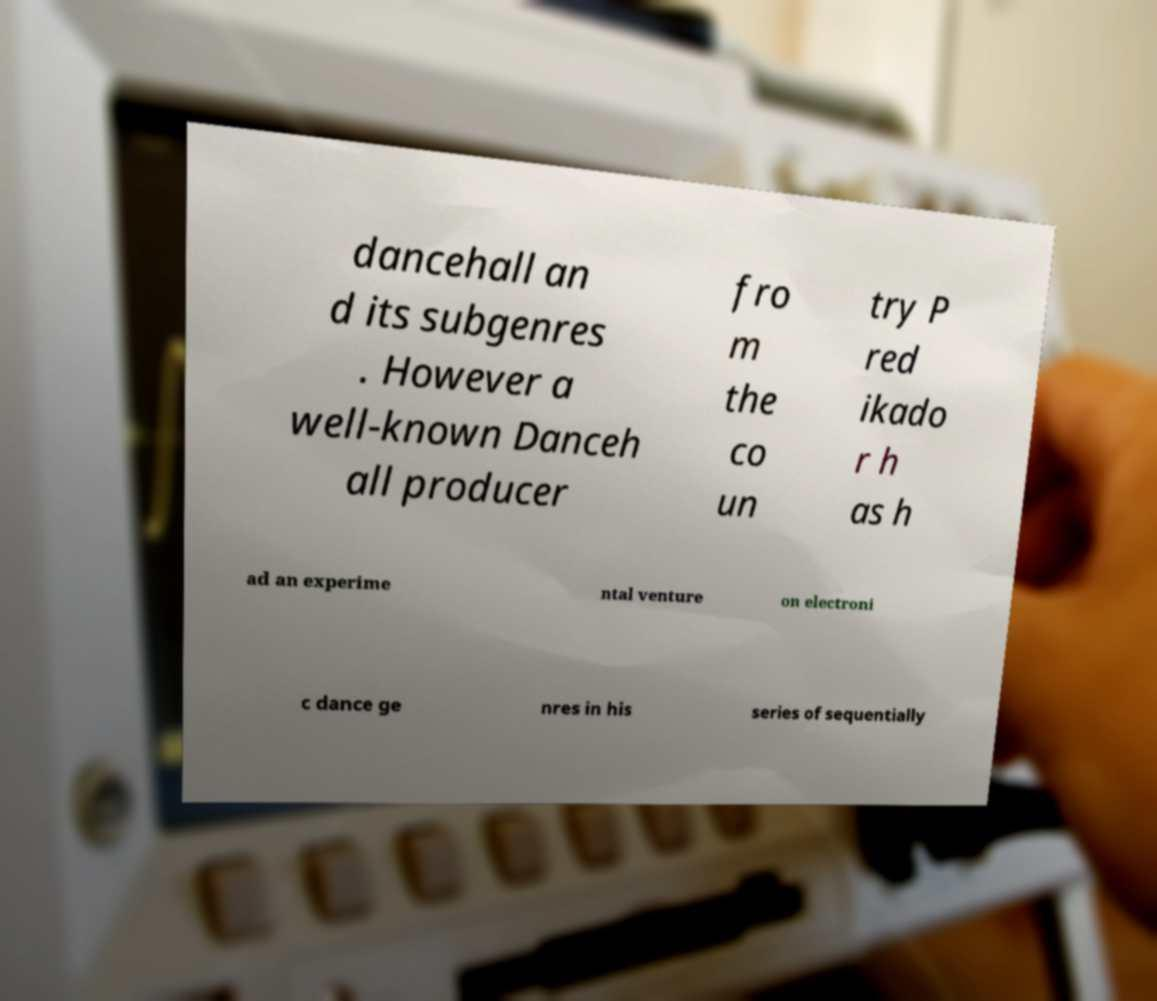For documentation purposes, I need the text within this image transcribed. Could you provide that? dancehall an d its subgenres . However a well-known Danceh all producer fro m the co un try P red ikado r h as h ad an experime ntal venture on electroni c dance ge nres in his series of sequentially 